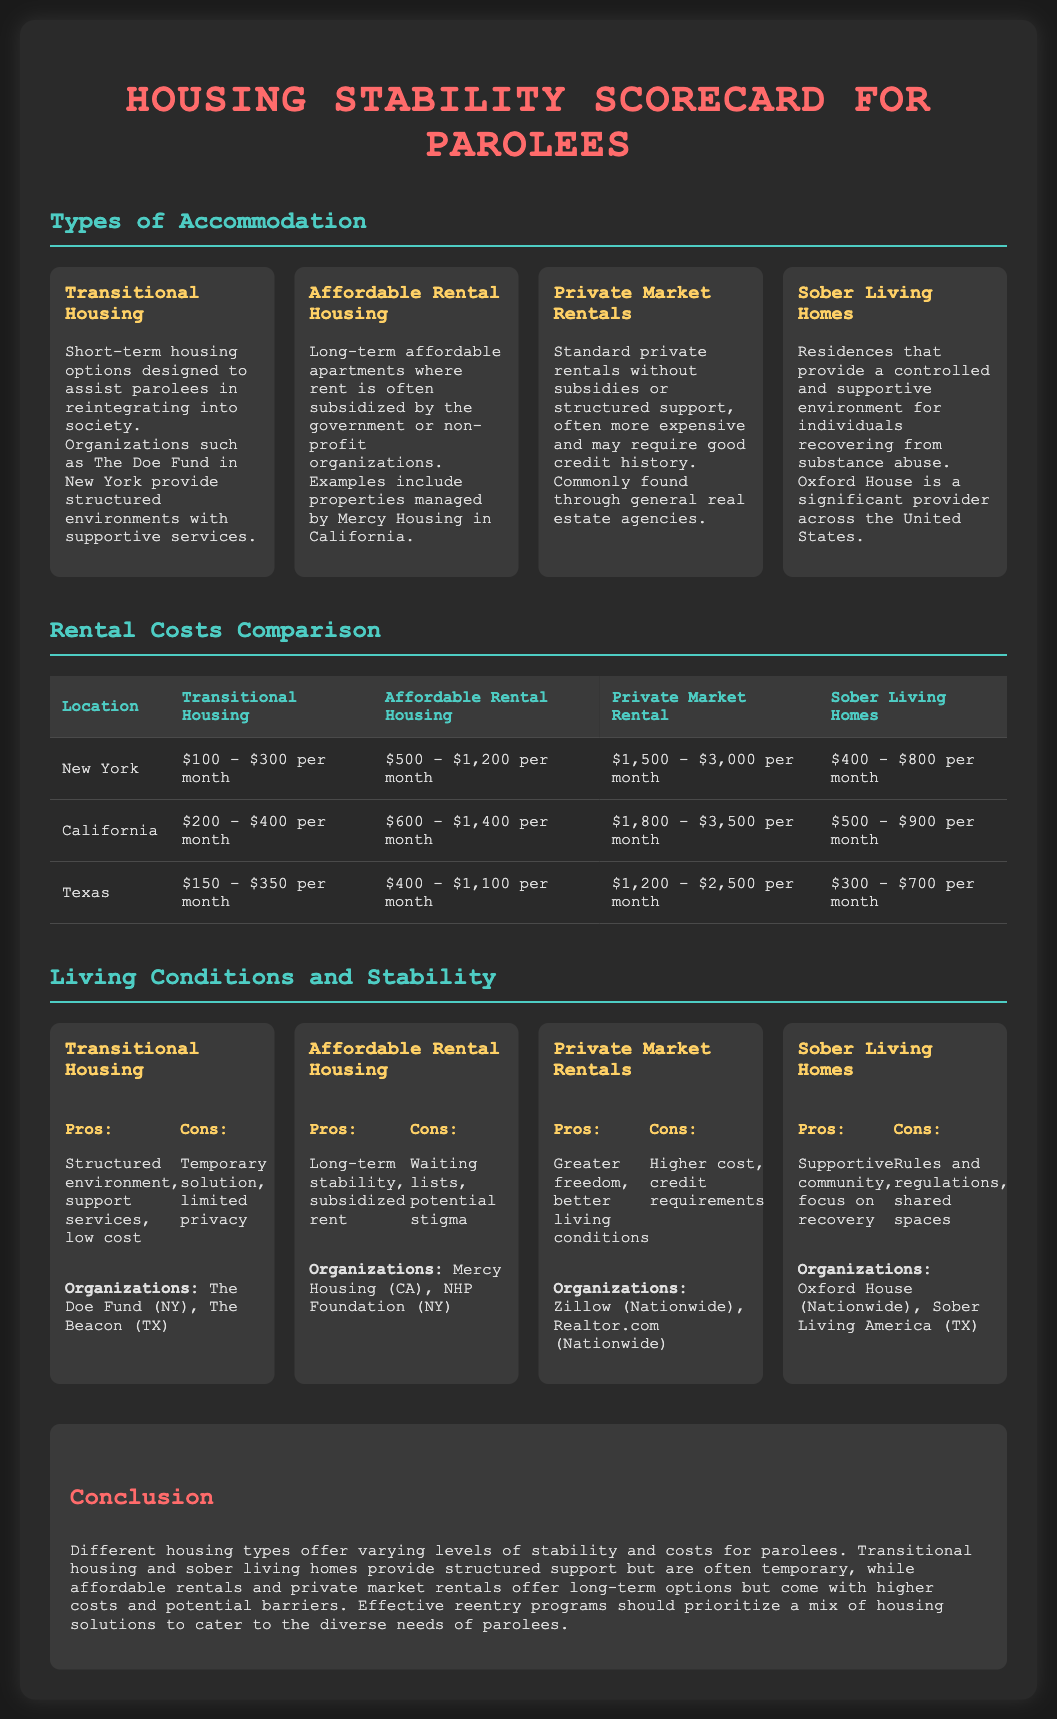what is the cost range for transitional housing in New York? The document lists the cost range for transitional housing in New York as $100 - $300 per month.
Answer: $100 - $300 per month which organization is mentioned for affordable rental housing in California? According to the document, Mercy Housing is the organization mentioned for affordable rental housing in California.
Answer: Mercy Housing (CA) what are the pros of sober living homes? The document states that the pros of sober living homes include a supportive community and focus on recovery.
Answer: Supportive community, focus on recovery what type of accommodation has the highest rental cost in Texas? The document provides a comparison of rental costs, indicating that private market rentals have the highest cost in Texas.
Answer: Private Market Rental what is a common con for transitional housing? The document mentions limited privacy as a common con for transitional housing.
Answer: Limited privacy which type of accommodation offers subsidized rent? The document specifies that affordable rental housing offers subsidized rent.
Answer: Affordable Rental Housing how does the rental cost of sober living homes compare to transitional housing in California? The comparison indicates that sober living homes range from $500 - $900 per month, while transitional housing ranges from $200 - $400 per month, making sober living homes generally more expensive.
Answer: More expensive what is the main focus of transitional housing? The document describes transitional housing as designed to assist parolees in reintegrating into society.
Answer: Reintegration into society 